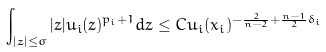Convert formula to latex. <formula><loc_0><loc_0><loc_500><loc_500>\int _ { | z | \leq \sigma } | z | u _ { i } ( z ) ^ { p _ { i } + 1 } d z \leq C u _ { i } ( x _ { i } ) ^ { - \frac { 2 } { n - 2 } + \frac { n - 1 } { 2 } \delta _ { i } }</formula> 